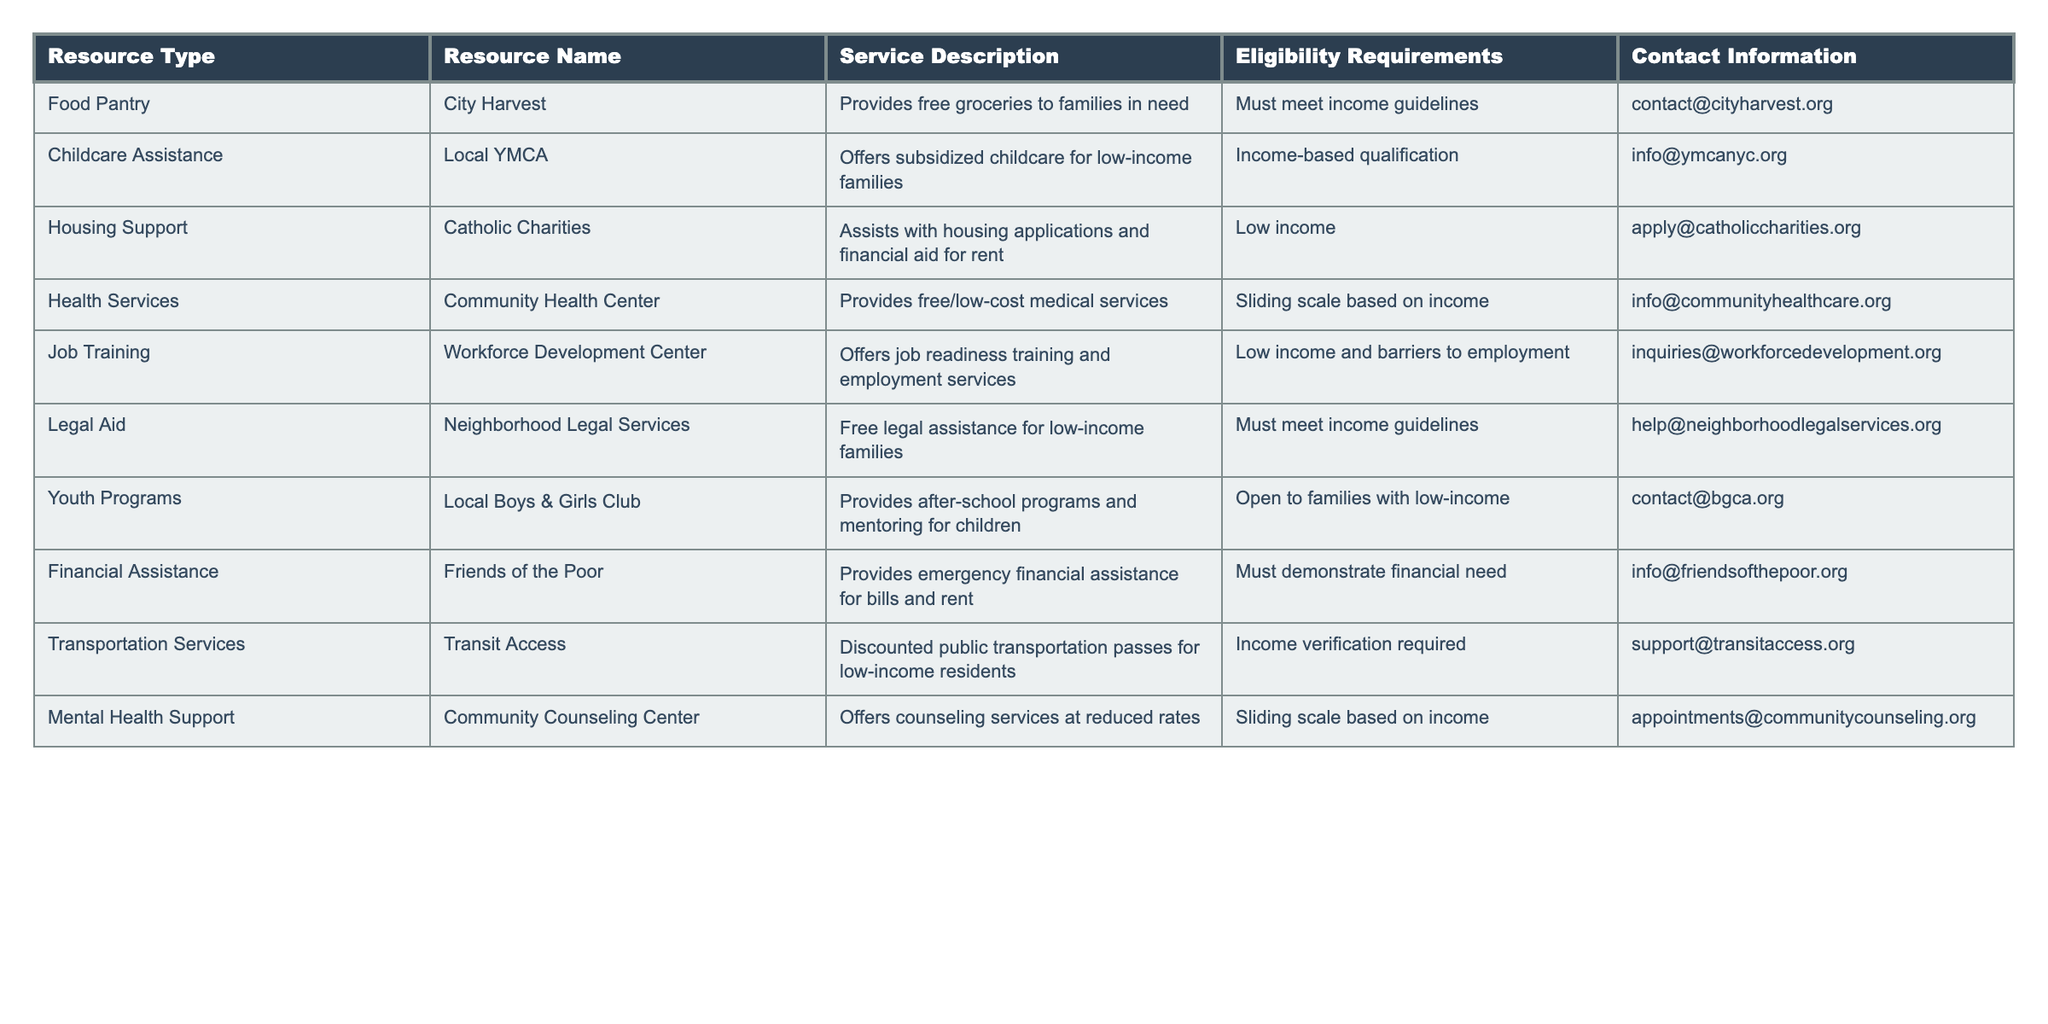What is the name of the organization that provides free groceries? The table lists "City Harvest" as the food pantry resource that provides free groceries.
Answer: City Harvest How many resources listed offer financial assistance of some sort? There are three resources that provide financial assistance: "Catholic Charities" (housing support), "Friends of the Poor" (emergency financial assistance), and "Neighborhood Legal Services" (free legal assistance).
Answer: Three Does the Local YMCA have eligibility requirements? Yes, the eligibility requirements for the Local YMCA are income-based qualifications, which are specified in the table.
Answer: Yes Which resource offers job readiness training? The resource that offers job readiness training is the "Workforce Development Center."
Answer: Workforce Development Center What do you need to qualify for the Community Health Center's services? To qualify for services at the Community Health Center, one must meet a sliding scale based on income according to the table.
Answer: Sliding scale based on income Compare the eligibility requirements for Legal Aid and Financial Assistance. Both Legal Aid and Financial Assistance require individuals to meet income guidelines, but Financial Assistance specifically requires demonstrating financial need in addition to this.
Answer: Similar, but Financial Assistance requires demonstrating financial need What is the main service provided by the Neighborhood Legal Services? The main service provided by the Neighborhood Legal Services is free legal assistance for low-income families.
Answer: Free legal assistance Which two resources provide services based on a sliding scale? The Community Health Center and the Community Counseling Center both provide services based on a sliding scale according to income.
Answer: Community Health Center and Community Counseling Center If a family is low income, how many different types of assistance can they potentially access? A low-income family can potentially access at least seven different types of assistance: food pantry, childcare assistance, housing support, health services, job training, legal aid, and youth programs.
Answer: Seven Is there any service that helps with transportation needs? Yes, "Transit Access" provides discounted public transportation passes for low-income residents.
Answer: Yes What information is needed to contact Friends of the Poor? The contact information for Friends of the Poor is listed as info@friendsofthepoor.org.
Answer: info@friendsofthepoor.org 